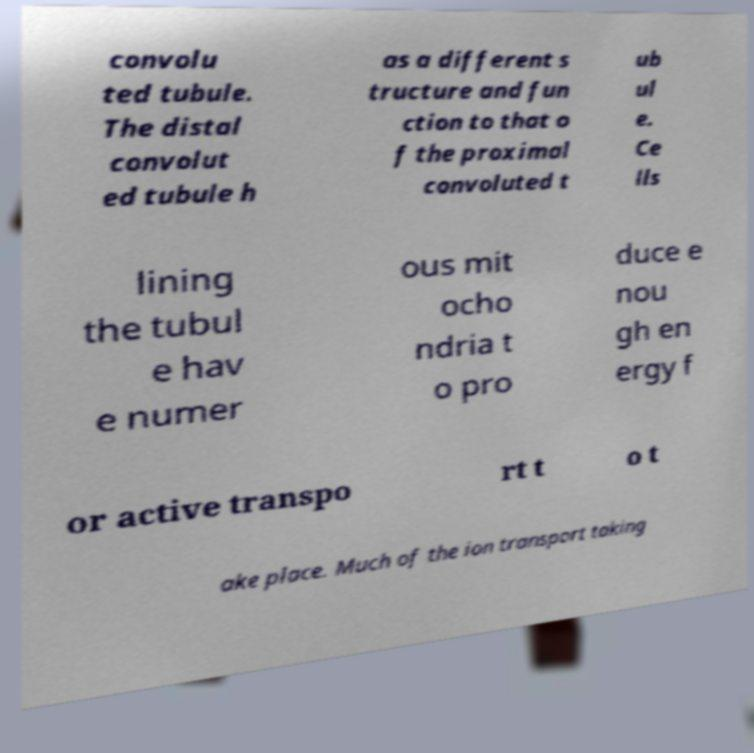What messages or text are displayed in this image? I need them in a readable, typed format. convolu ted tubule. The distal convolut ed tubule h as a different s tructure and fun ction to that o f the proximal convoluted t ub ul e. Ce lls lining the tubul e hav e numer ous mit ocho ndria t o pro duce e nou gh en ergy f or active transpo rt t o t ake place. Much of the ion transport taking 